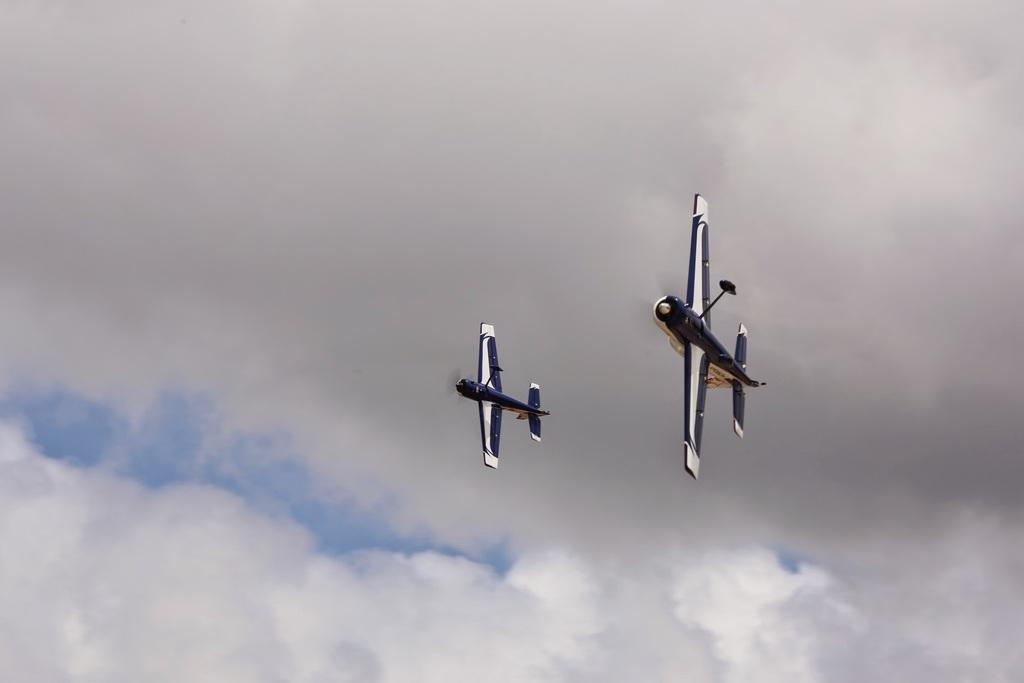What is the main subject of the image? The main subject of the image is two aircrafts. What can be said about the color of the aircrafts? The aircrafts are black and white in color. What are the aircrafts doing in the image? The aircrafts are flying in the air. What can be seen in the background of the image? The sky is visible in the background of the image. Can you tell me how many tigers are sitting on the aircrafts in the image? There are no tigers present in the image; the main subjects are the two aircrafts. What type of credit card is being used to pay for the flight in the image? There is no credit card or payment being depicted in the image; it only shows two aircrafts flying in the air. 